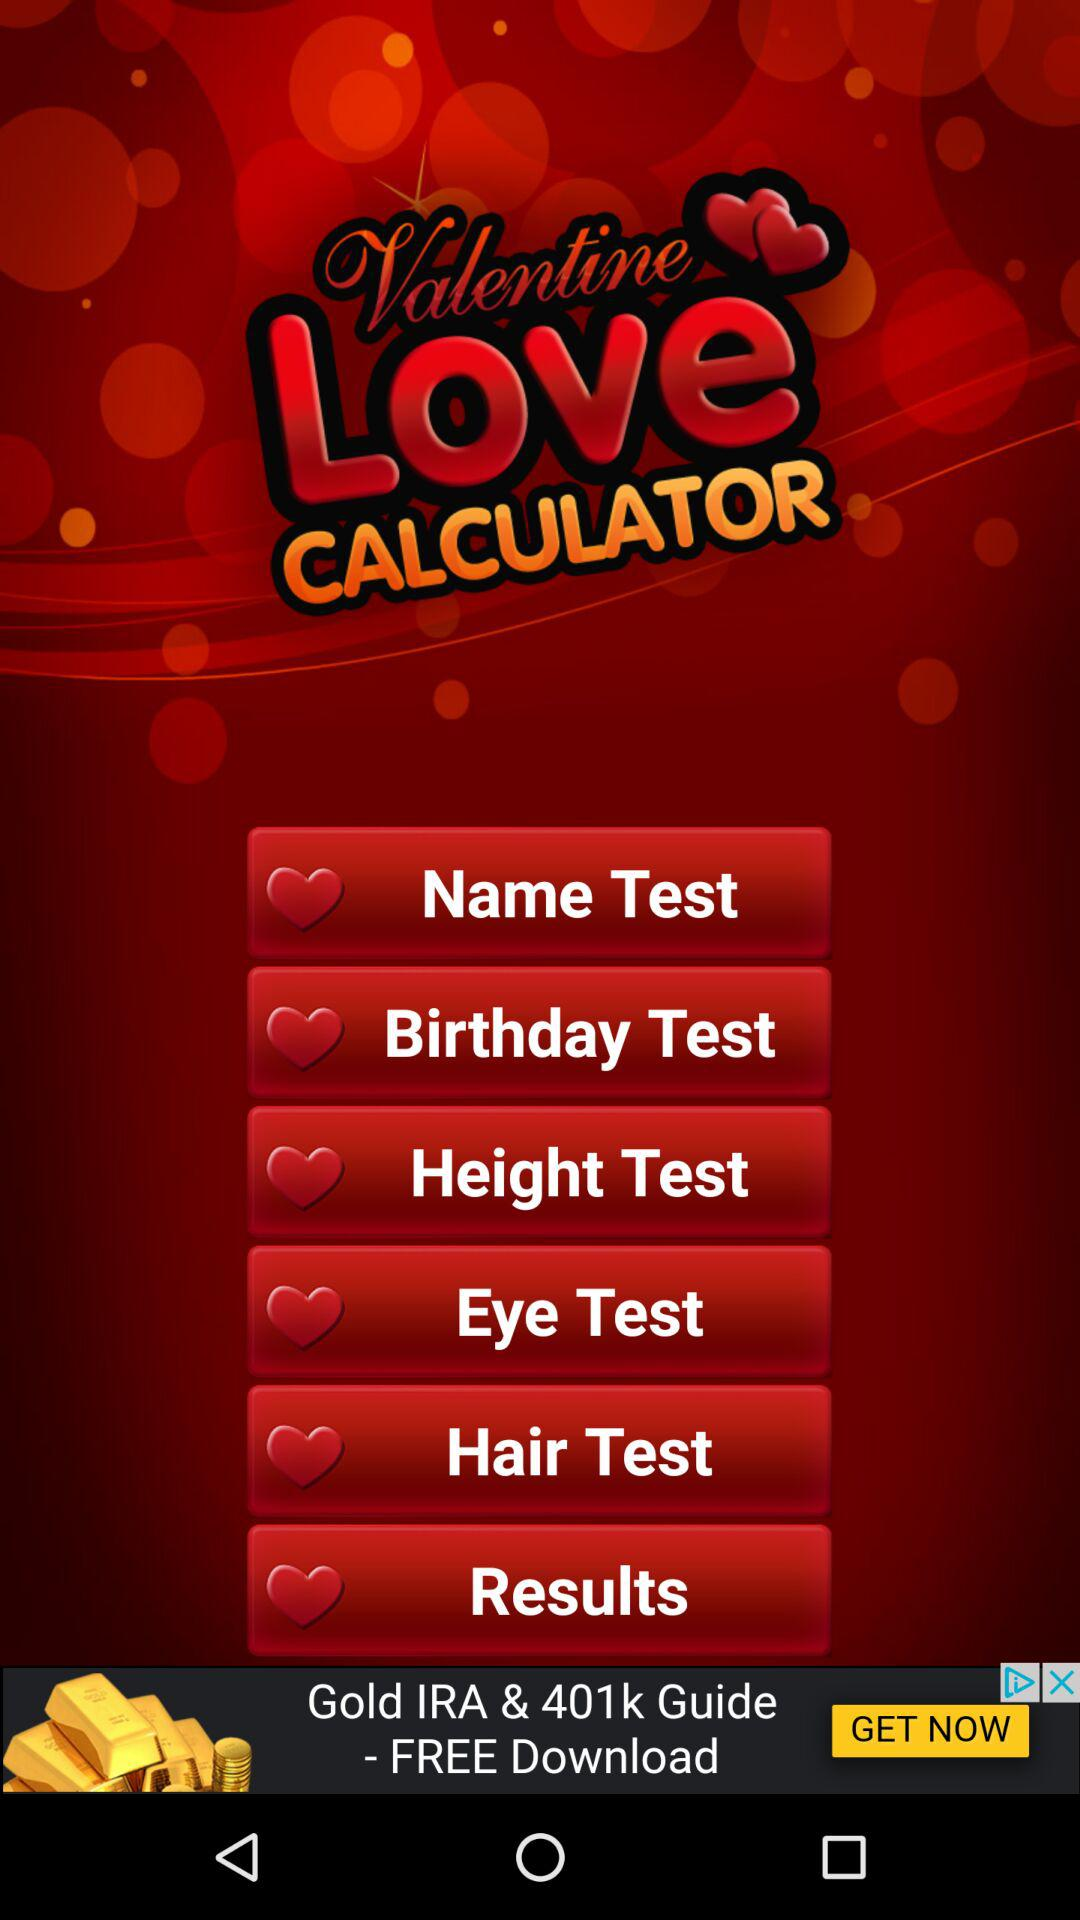How many questions are in "Name Test"?
When the provided information is insufficient, respond with <no answer>. <no answer> 